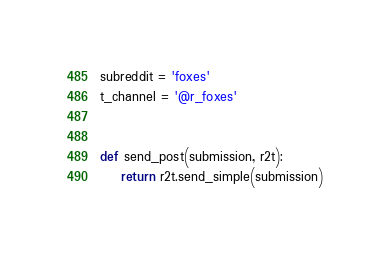Convert code to text. <code><loc_0><loc_0><loc_500><loc_500><_Python_>subreddit = 'foxes'
t_channel = '@r_foxes'


def send_post(submission, r2t):
    return r2t.send_simple(submission)
</code> 